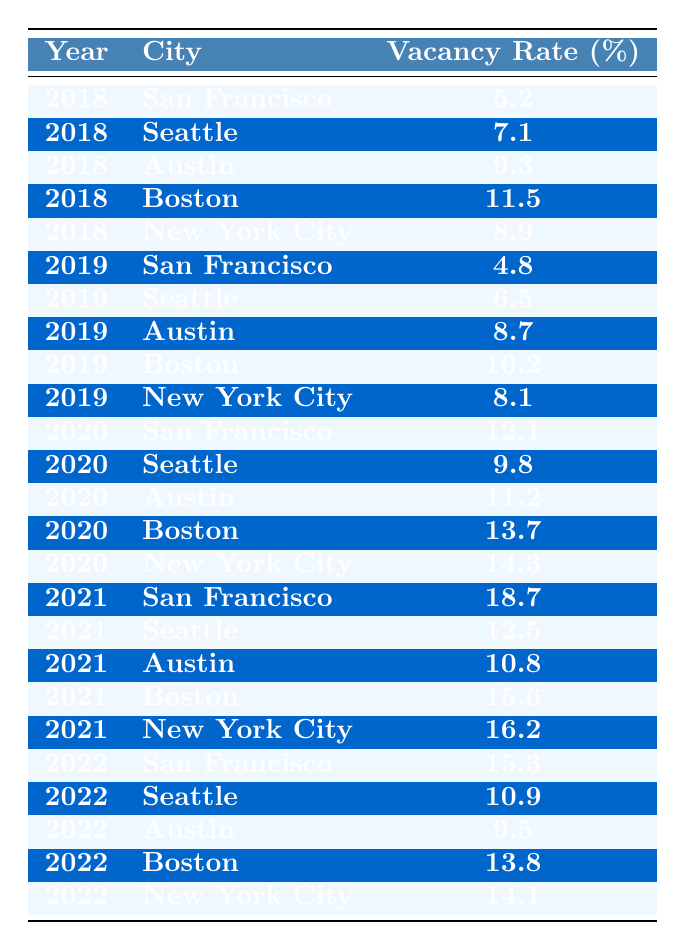What was the vacancy rate in San Francisco in 2020? Looking at the row for San Francisco under the year 2020, the vacancy rate is listed as 12.1%.
Answer: 12.1% Which city had the highest vacancy rate in 2021? In 2021, the vacancy rates for the cities are: San Francisco (18.7%), Seattle (12.5%), Austin (10.8%), Boston (15.6%), and New York City (16.2%). The highest is San Francisco with 18.7%.
Answer: San Francisco What is the average vacancy rate for Austin over the five years? The vacancy rates for Austin from 2018 to 2022 are 9.3%, 8.7%, 11.2%, 10.8%, and 9.5%. The sum is 49.5%, and dividing by 5 gives an average of 9.9%.
Answer: 9.9% Was there a significant increase in the vacancy rate for New York City from 2018 to 2021? The vacancy rates for New York City are 8.9% in 2018 and 16.2% in 2021. The change is 16.2% - 8.9% = 7.3%, indicating a significant increase.
Answer: Yes Which city's vacancy rate improved the most from 2019 to 2020? In 2019, the vacancy rates were: San Francisco (4.8%), Seattle (6.5%), Austin (8.7%), Boston (10.2%), and New York City (8.1%). In 2020, they changed to San Francisco (12.1%), Seattle (9.8%), Austin (11.2%), Boston (13.7%), and New York City (14.3%). The greatest improvement is a reduction for Seattle, from 6.5% to 9.8%.
Answer: Seattle What was the change in vacancy rate for Seattle from 2018 to 2022? The vacancy rate for Seattle in 2018 was 7.1% and in 2022 it was 10.9%. The change is 10.9% - 7.1% = 3.8%.
Answer: 3.8% What is the overall trend in vacancy rates for San Francisco from 2018 to 2022? The vacancy rates for San Francisco from 2018 to 2022 are 5.2%, 4.8%, 12.1%, 18.7%, and 15.3%. The trend shows a general increase followed by a slight decrease, but it's largely upward overall.
Answer: Increasing In which year did Boston see the lowest vacancy rate? The vacancy rates for Boston are: 11.5% in 2018, 10.2% in 2019, 13.7% in 2020, 15.6% in 2021, and 13.8% in 2022. The lowest rate is in 2019 at 10.2%.
Answer: 2019 What was the average vacancy rate across all cities for the year 2022? The vacancy rates for all cities in 2022 are: San Francisco (15.3%), Seattle (10.9%), Austin (9.5%), Boston (13.8%), and New York City (14.1%). The total is 15.3% + 10.9% + 9.5% + 13.8% + 14.1% = 63.6%. Dividing by 5 gives an average of 12.72%.
Answer: 12.72% Which two cities had the closest vacancy rates in 2020? The vacancy rates for 2020 are: San Francisco (12.1%), Seattle (9.8%), Austin (11.2%), Boston (13.7%), and New York City (14.3%). Comparing them, Austin at 11.2% and Seattle at 9.8% had the closest rates.
Answer: Austin and Seattle 